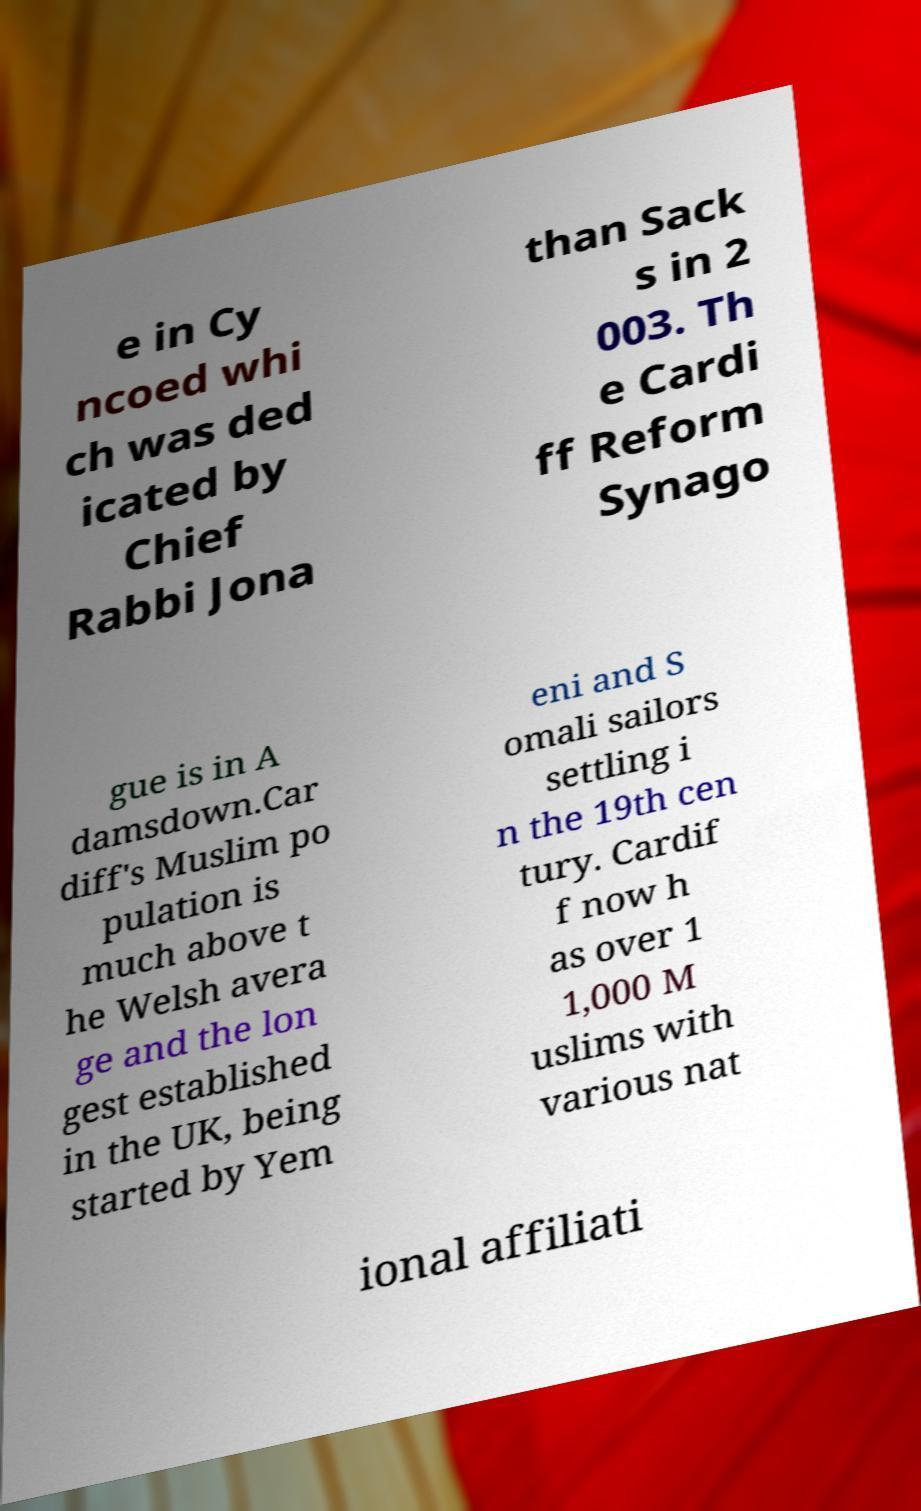Can you read and provide the text displayed in the image?This photo seems to have some interesting text. Can you extract and type it out for me? e in Cy ncoed whi ch was ded icated by Chief Rabbi Jona than Sack s in 2 003. Th e Cardi ff Reform Synago gue is in A damsdown.Car diff's Muslim po pulation is much above t he Welsh avera ge and the lon gest established in the UK, being started by Yem eni and S omali sailors settling i n the 19th cen tury. Cardif f now h as over 1 1,000 M uslims with various nat ional affiliati 